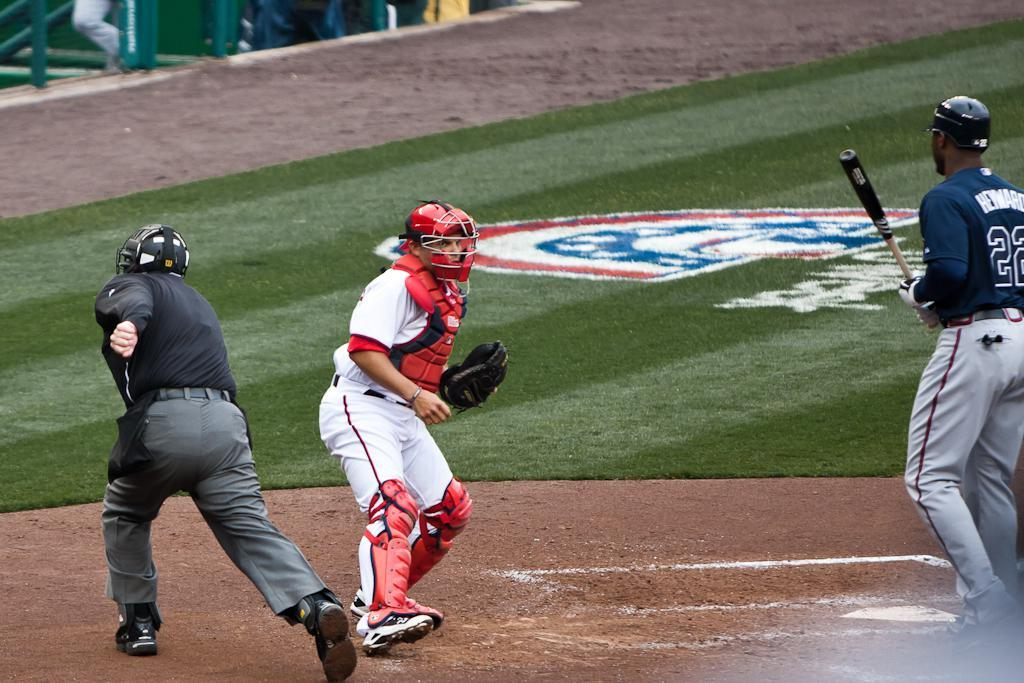Provide a one-sentence caption for the provided image. A black man with Heward on the back of his jersey holds a baseball bat on the field. 